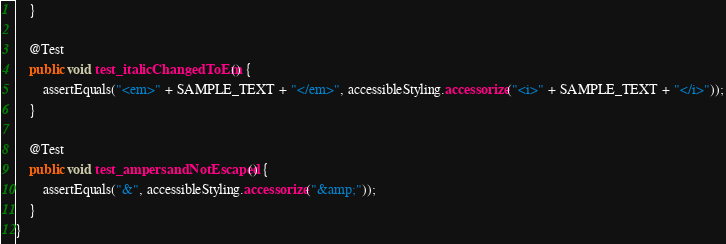<code> <loc_0><loc_0><loc_500><loc_500><_Java_>    }

    @Test
    public void test_italicChangedToEm() {
        assertEquals("<em>" + SAMPLE_TEXT + "</em>", accessibleStyling.accessorize("<i>" + SAMPLE_TEXT + "</i>"));
    }

    @Test
    public void test_ampersandNotEscaped() {
        assertEquals("&", accessibleStyling.accessorize("&amp;"));
    }
}
</code> 